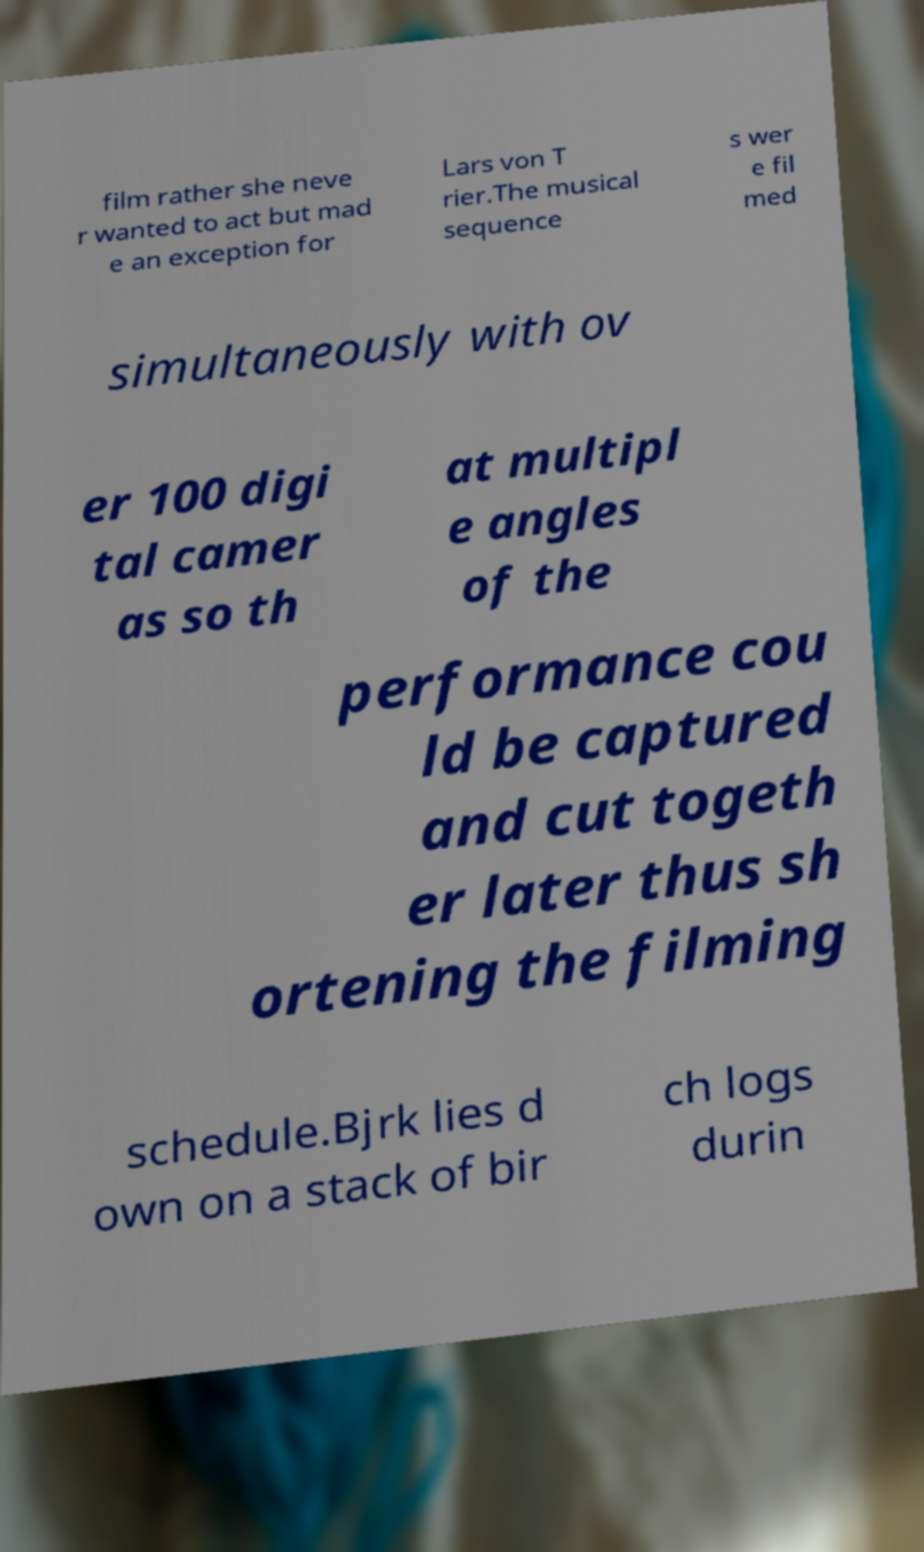I need the written content from this picture converted into text. Can you do that? film rather she neve r wanted to act but mad e an exception for Lars von T rier.The musical sequence s wer e fil med simultaneously with ov er 100 digi tal camer as so th at multipl e angles of the performance cou ld be captured and cut togeth er later thus sh ortening the filming schedule.Bjrk lies d own on a stack of bir ch logs durin 